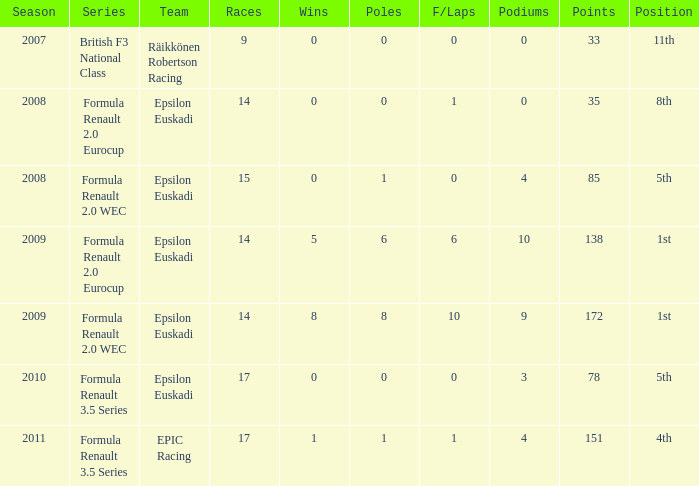What team was he on when he finished in 11th position? Räikkönen Robertson Racing. 